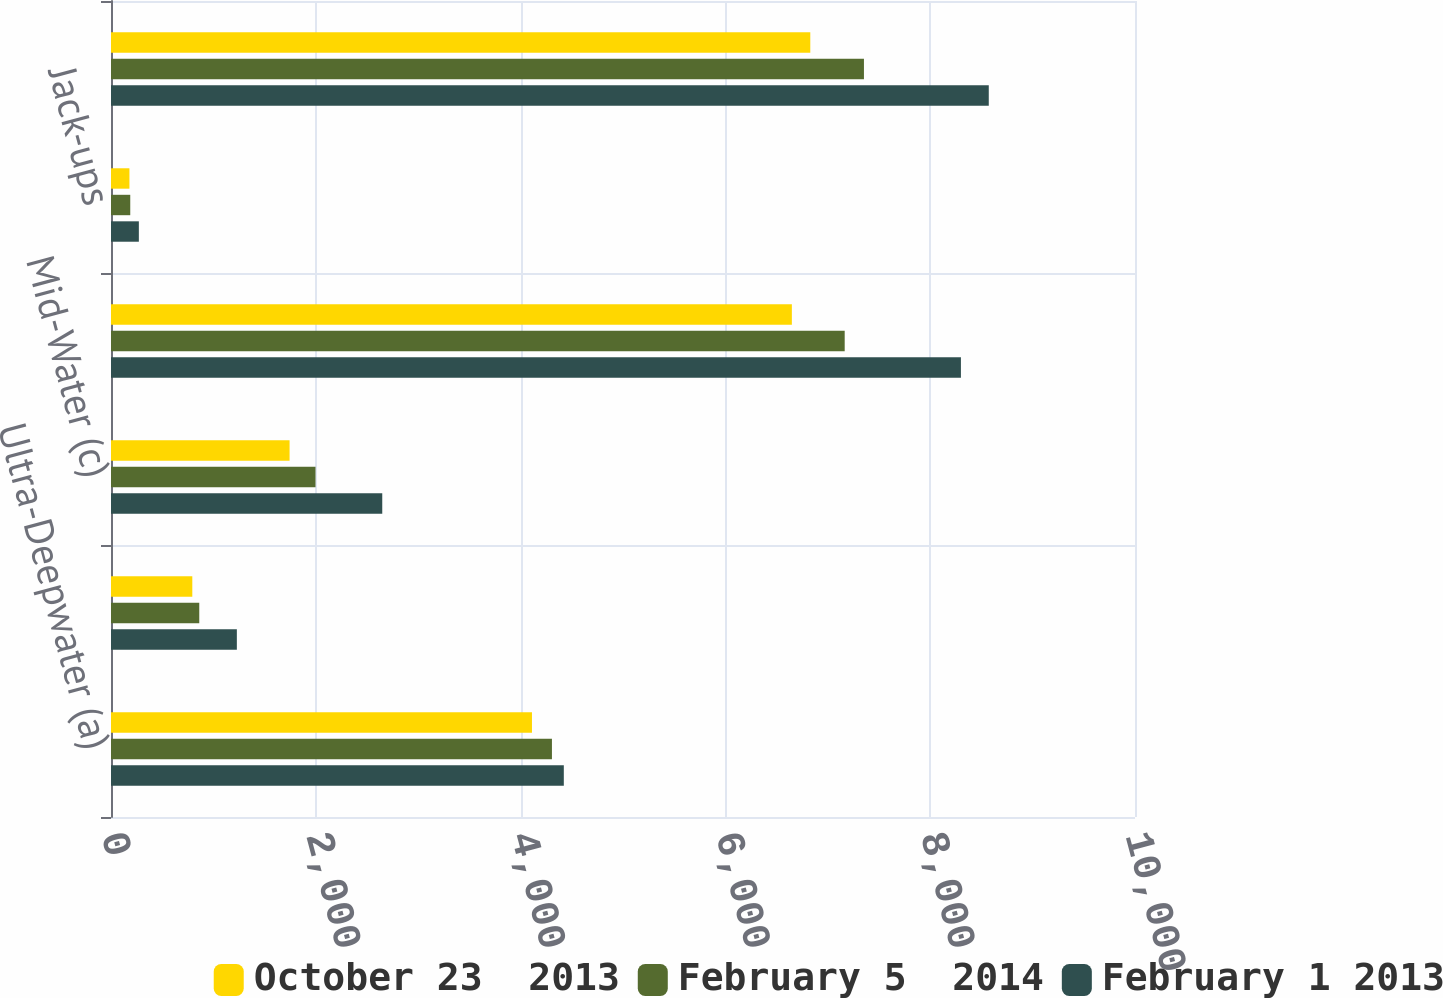Convert chart to OTSL. <chart><loc_0><loc_0><loc_500><loc_500><stacked_bar_chart><ecel><fcel>Ultra-Deepwater (a)<fcel>Deepwater (b)<fcel>Mid-Water (c)<fcel>Total Floaters<fcel>Jack-ups<fcel>Total<nl><fcel>October 23  2013<fcel>4111<fcel>794<fcel>1744<fcel>6649<fcel>180<fcel>6829<nl><fcel>February 5  2014<fcel>4306<fcel>862<fcel>1997<fcel>7165<fcel>188<fcel>7353<nl><fcel>February 1 2013<fcel>4422<fcel>1229<fcel>2649<fcel>8300<fcel>272<fcel>8572<nl></chart> 